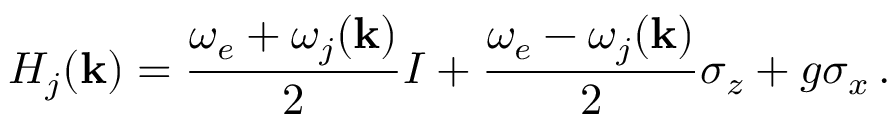<formula> <loc_0><loc_0><loc_500><loc_500>H _ { j } ( \mathbf k ) = \frac { \omega _ { e } + \omega _ { j } ( \mathbf k ) } { 2 } I + \frac { \omega _ { e } - \omega _ { j } ( \mathbf k ) } { 2 } \sigma _ { z } + g \sigma _ { x } \, .</formula> 